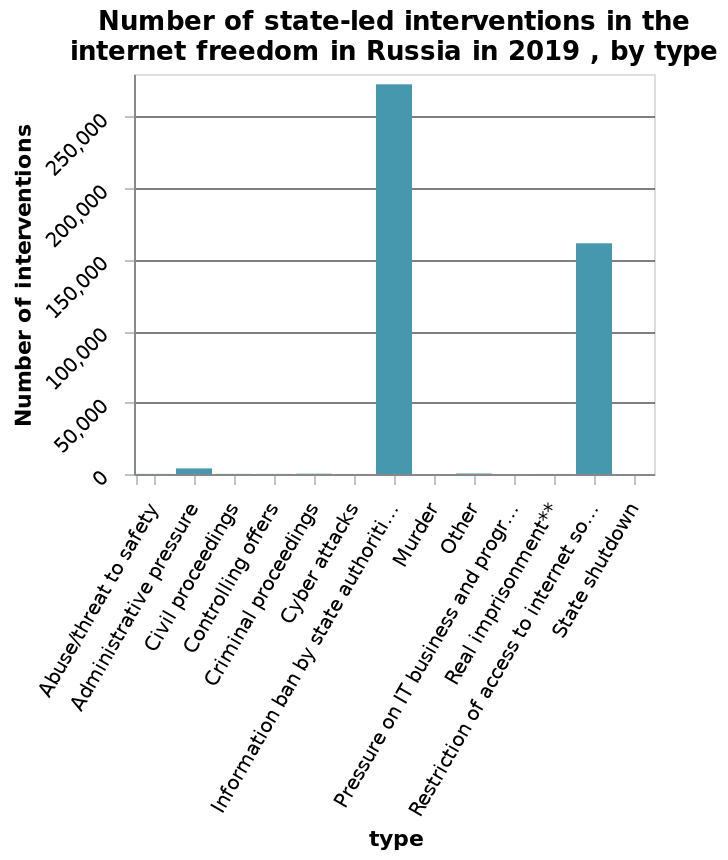<image>
Offer a thorough analysis of the image. The highest number of state-led interventions in the internet freedoms in Russia in 2019 was of the type "information ban by state authorities". The second highest was "restriction of access to the internet so...". The third highest was "administrative pressure", while the remaining types did not have any interventions. Which type of state-led intervention ranked third in terms of frequency in internet freedoms in Russia in 2019?  The type of state-led intervention that ranked third in terms of frequency in internet freedoms in Russia in 2019 was "administrative pressure". 